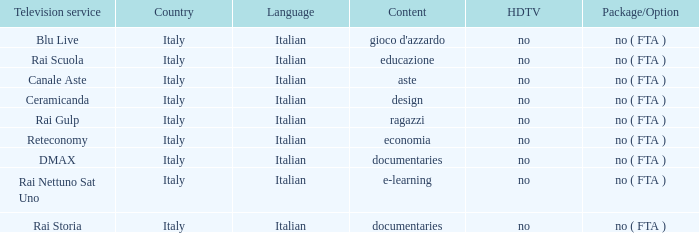What is the Country with Reteconomy as the Television service? Italy. 